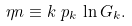<formula> <loc_0><loc_0><loc_500><loc_500>\eta n & \equiv k \ p _ { k } \, \ln G _ { k } .</formula> 